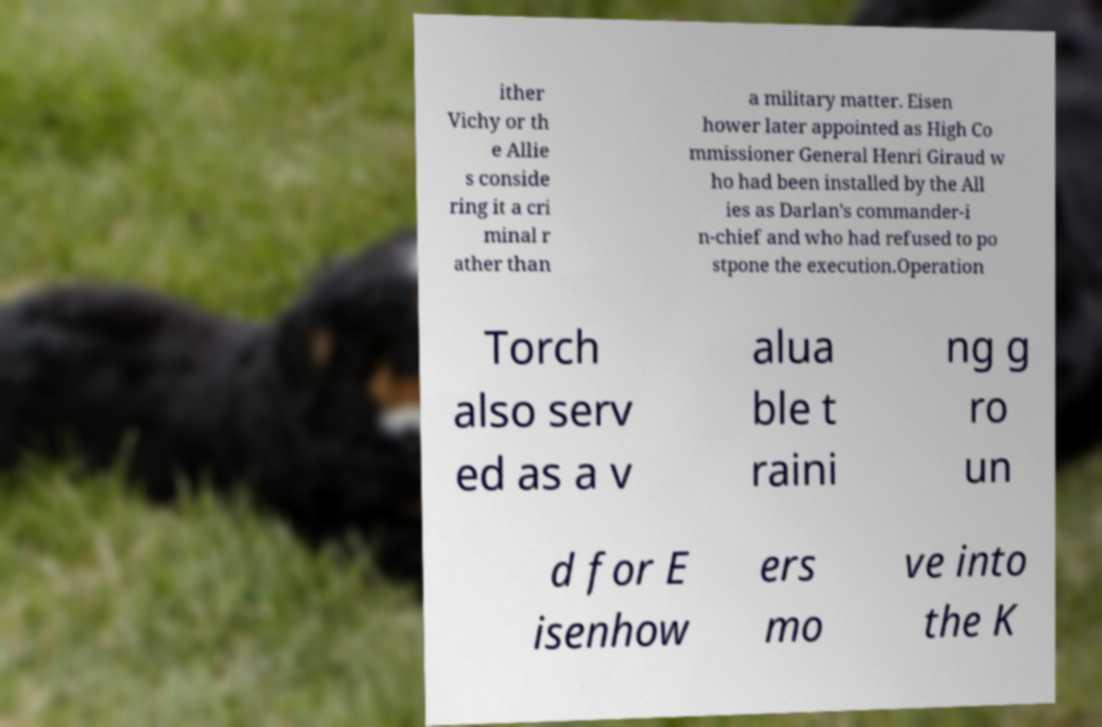I need the written content from this picture converted into text. Can you do that? ither Vichy or th e Allie s conside ring it a cri minal r ather than a military matter. Eisen hower later appointed as High Co mmissioner General Henri Giraud w ho had been installed by the All ies as Darlan's commander-i n-chief and who had refused to po stpone the execution.Operation Torch also serv ed as a v alua ble t raini ng g ro un d for E isenhow ers mo ve into the K 